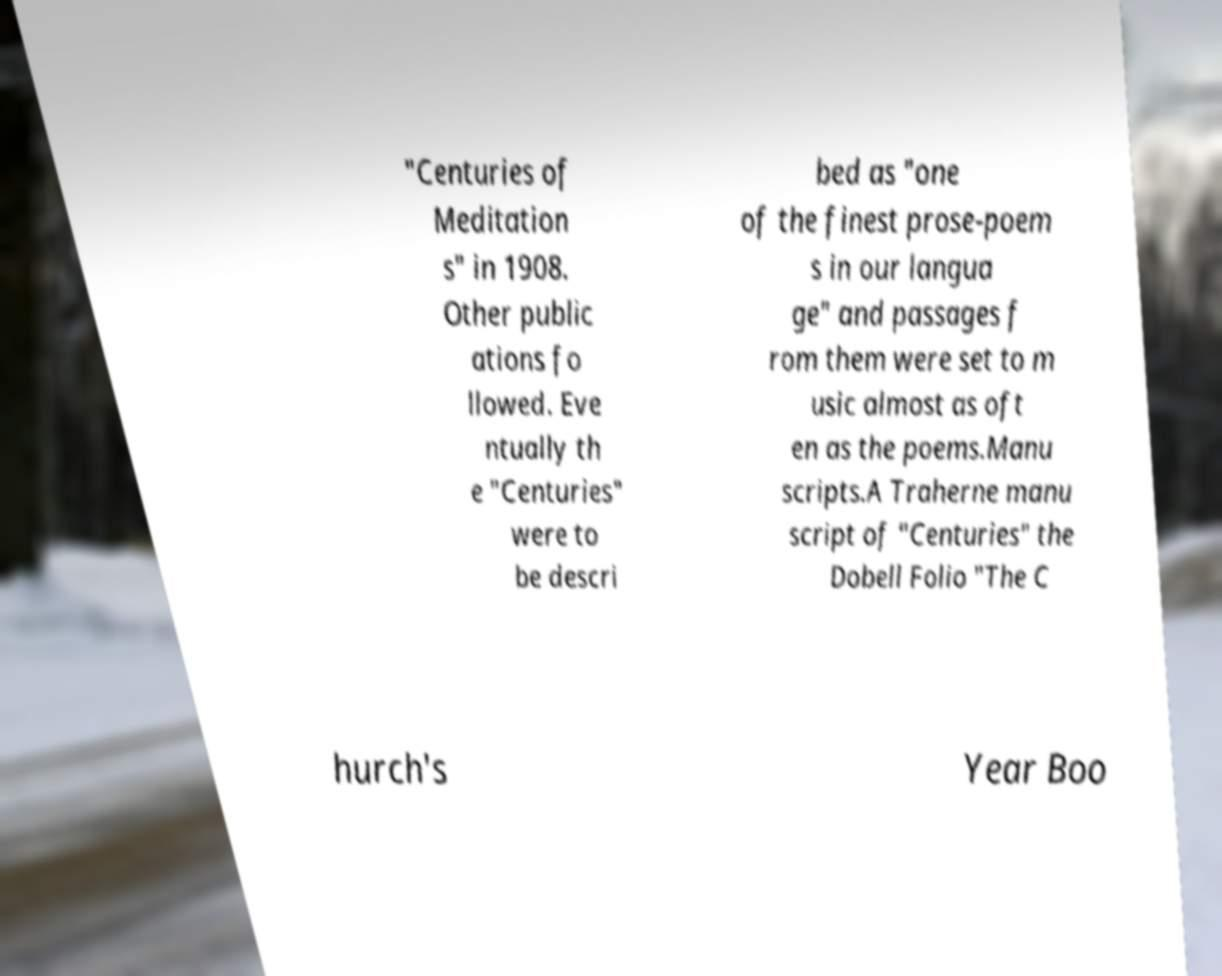There's text embedded in this image that I need extracted. Can you transcribe it verbatim? "Centuries of Meditation s" in 1908. Other public ations fo llowed. Eve ntually th e "Centuries" were to be descri bed as "one of the finest prose-poem s in our langua ge" and passages f rom them were set to m usic almost as oft en as the poems.Manu scripts.A Traherne manu script of "Centuries" the Dobell Folio "The C hurch's Year Boo 